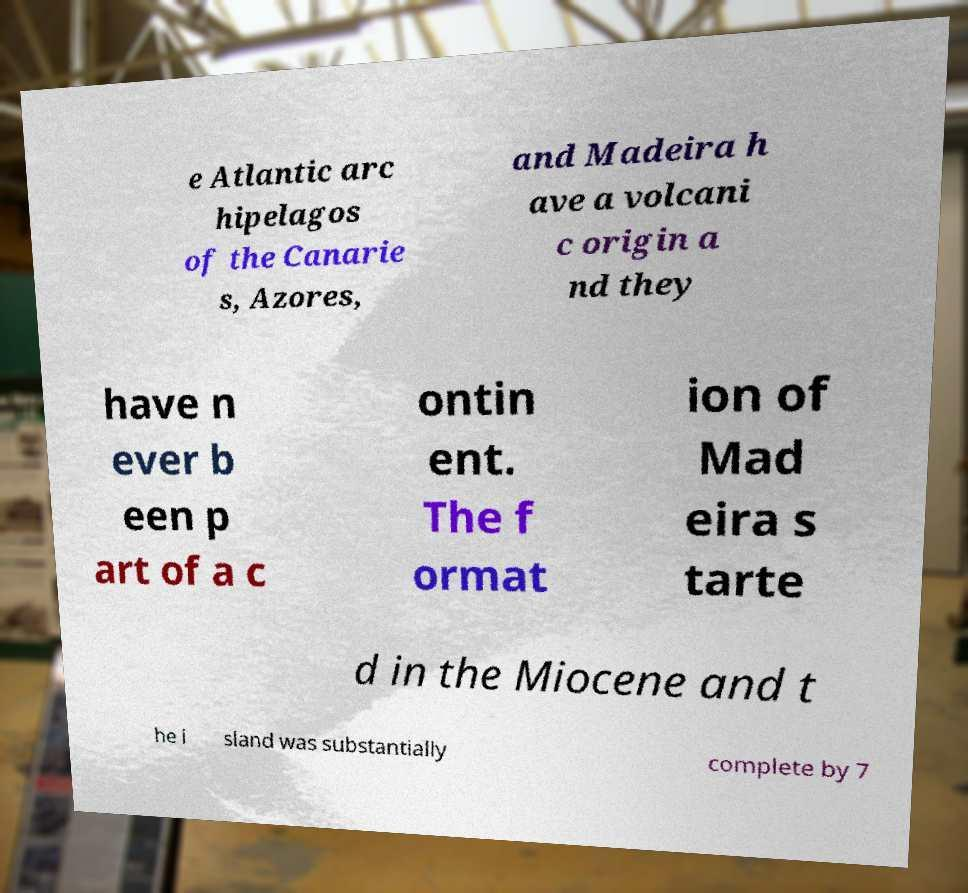Please identify and transcribe the text found in this image. e Atlantic arc hipelagos of the Canarie s, Azores, and Madeira h ave a volcani c origin a nd they have n ever b een p art of a c ontin ent. The f ormat ion of Mad eira s tarte d in the Miocene and t he i sland was substantially complete by 7 